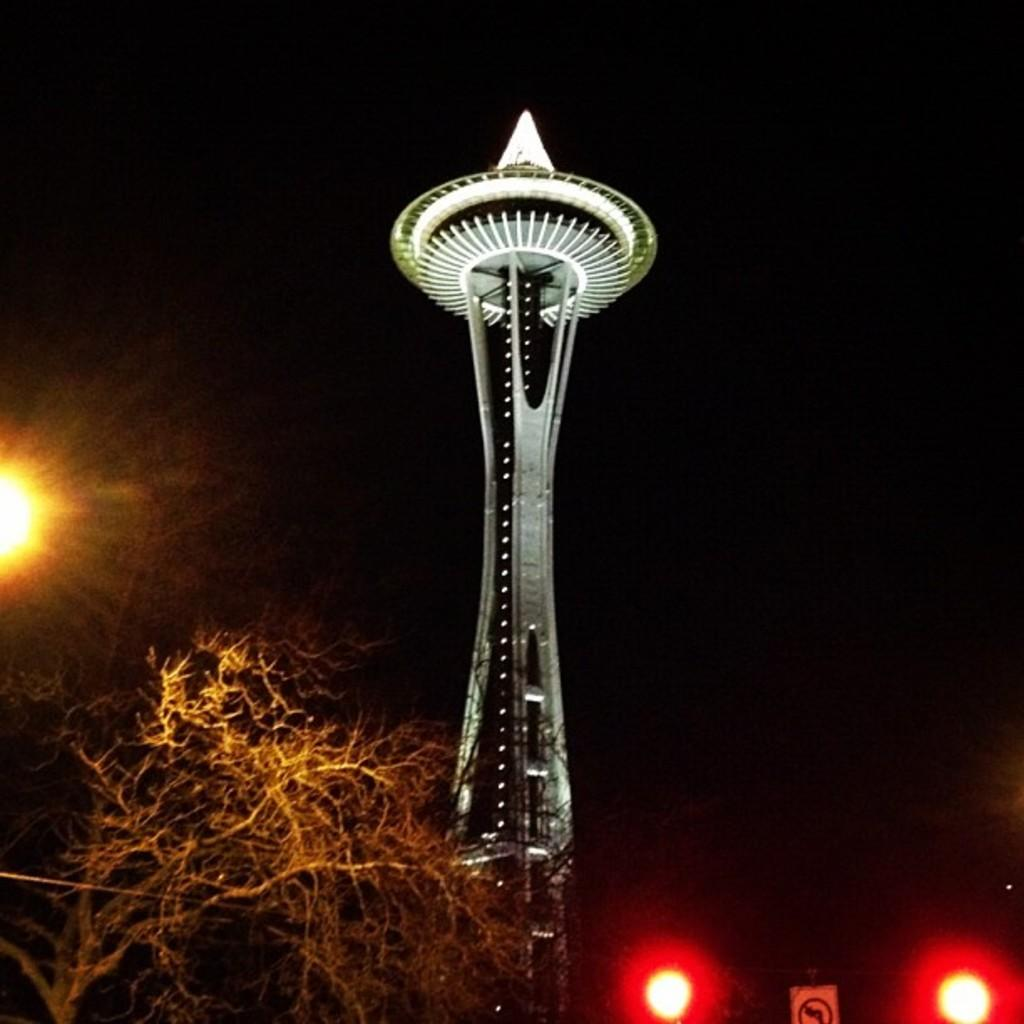What is the main structure visible in the image? There is an object that looks like a tower in the image. What type of natural element can be seen in the image? There is a tree in the image. What is the profit made from the volleyball game in the image? There is no volleyball game present in the image, so it's not possible to determine any profit made from it. 